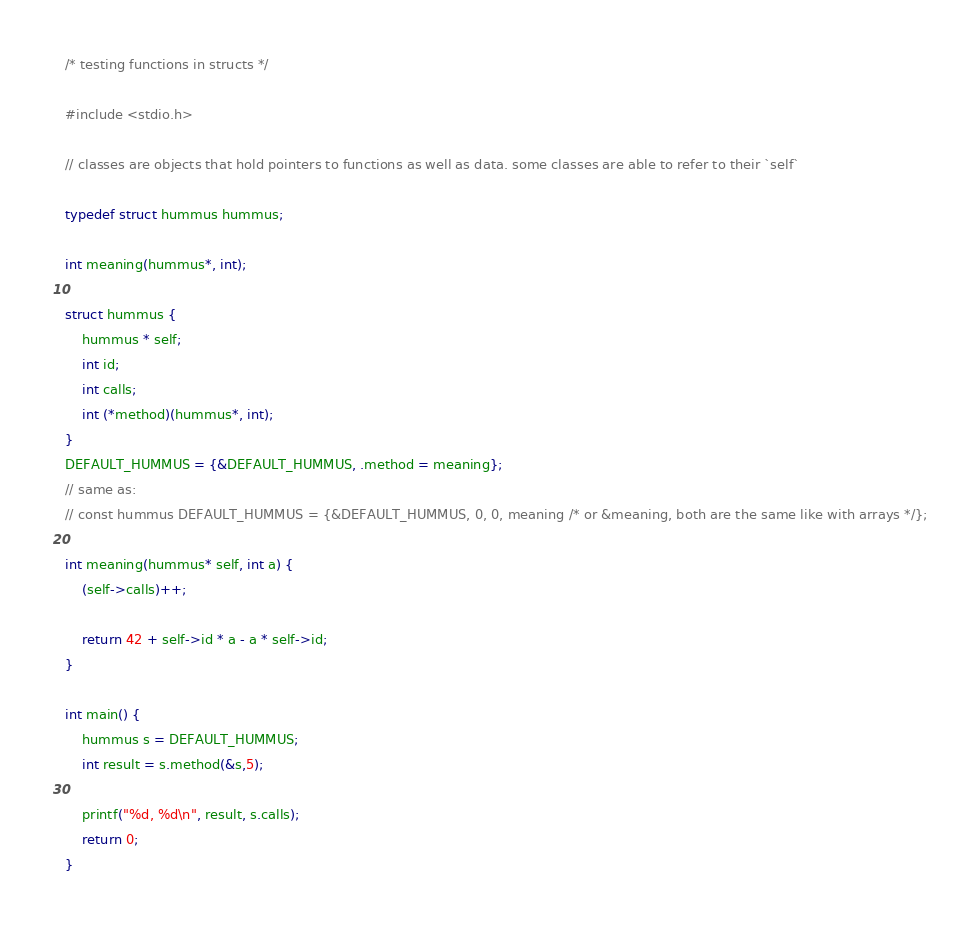<code> <loc_0><loc_0><loc_500><loc_500><_C_>/* testing functions in structs */

#include <stdio.h>

// classes are objects that hold pointers to functions as well as data. some classes are able to refer to their `self`

typedef struct hummus hummus;

int meaning(hummus*, int);

struct hummus {
	hummus * self;
	int id;
	int calls;
	int (*method)(hummus*, int);
}
DEFAULT_HUMMUS = {&DEFAULT_HUMMUS, .method = meaning};
// same as:
// const hummus DEFAULT_HUMMUS = {&DEFAULT_HUMMUS, 0, 0, meaning /* or &meaning, both are the same like with arrays */};

int meaning(hummus* self, int a) {
	(self->calls)++;

	return 42 + self->id * a - a * self->id;
}

int main() {
	hummus s = DEFAULT_HUMMUS;
	int result = s.method(&s,5);

	printf("%d, %d\n", result, s.calls);
	return 0;
}
</code> 